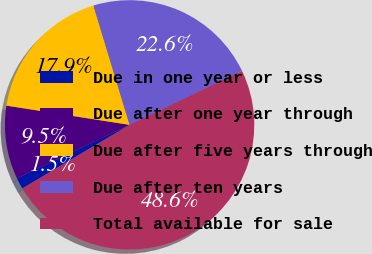Convert chart to OTSL. <chart><loc_0><loc_0><loc_500><loc_500><pie_chart><fcel>Due in one year or less<fcel>Due after one year through<fcel>Due after five years through<fcel>Due after ten years<fcel>Total available for sale<nl><fcel>1.45%<fcel>9.53%<fcel>17.85%<fcel>22.56%<fcel>48.61%<nl></chart> 